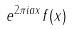<formula> <loc_0><loc_0><loc_500><loc_500>e ^ { 2 \pi i a x } f ( x )</formula> 